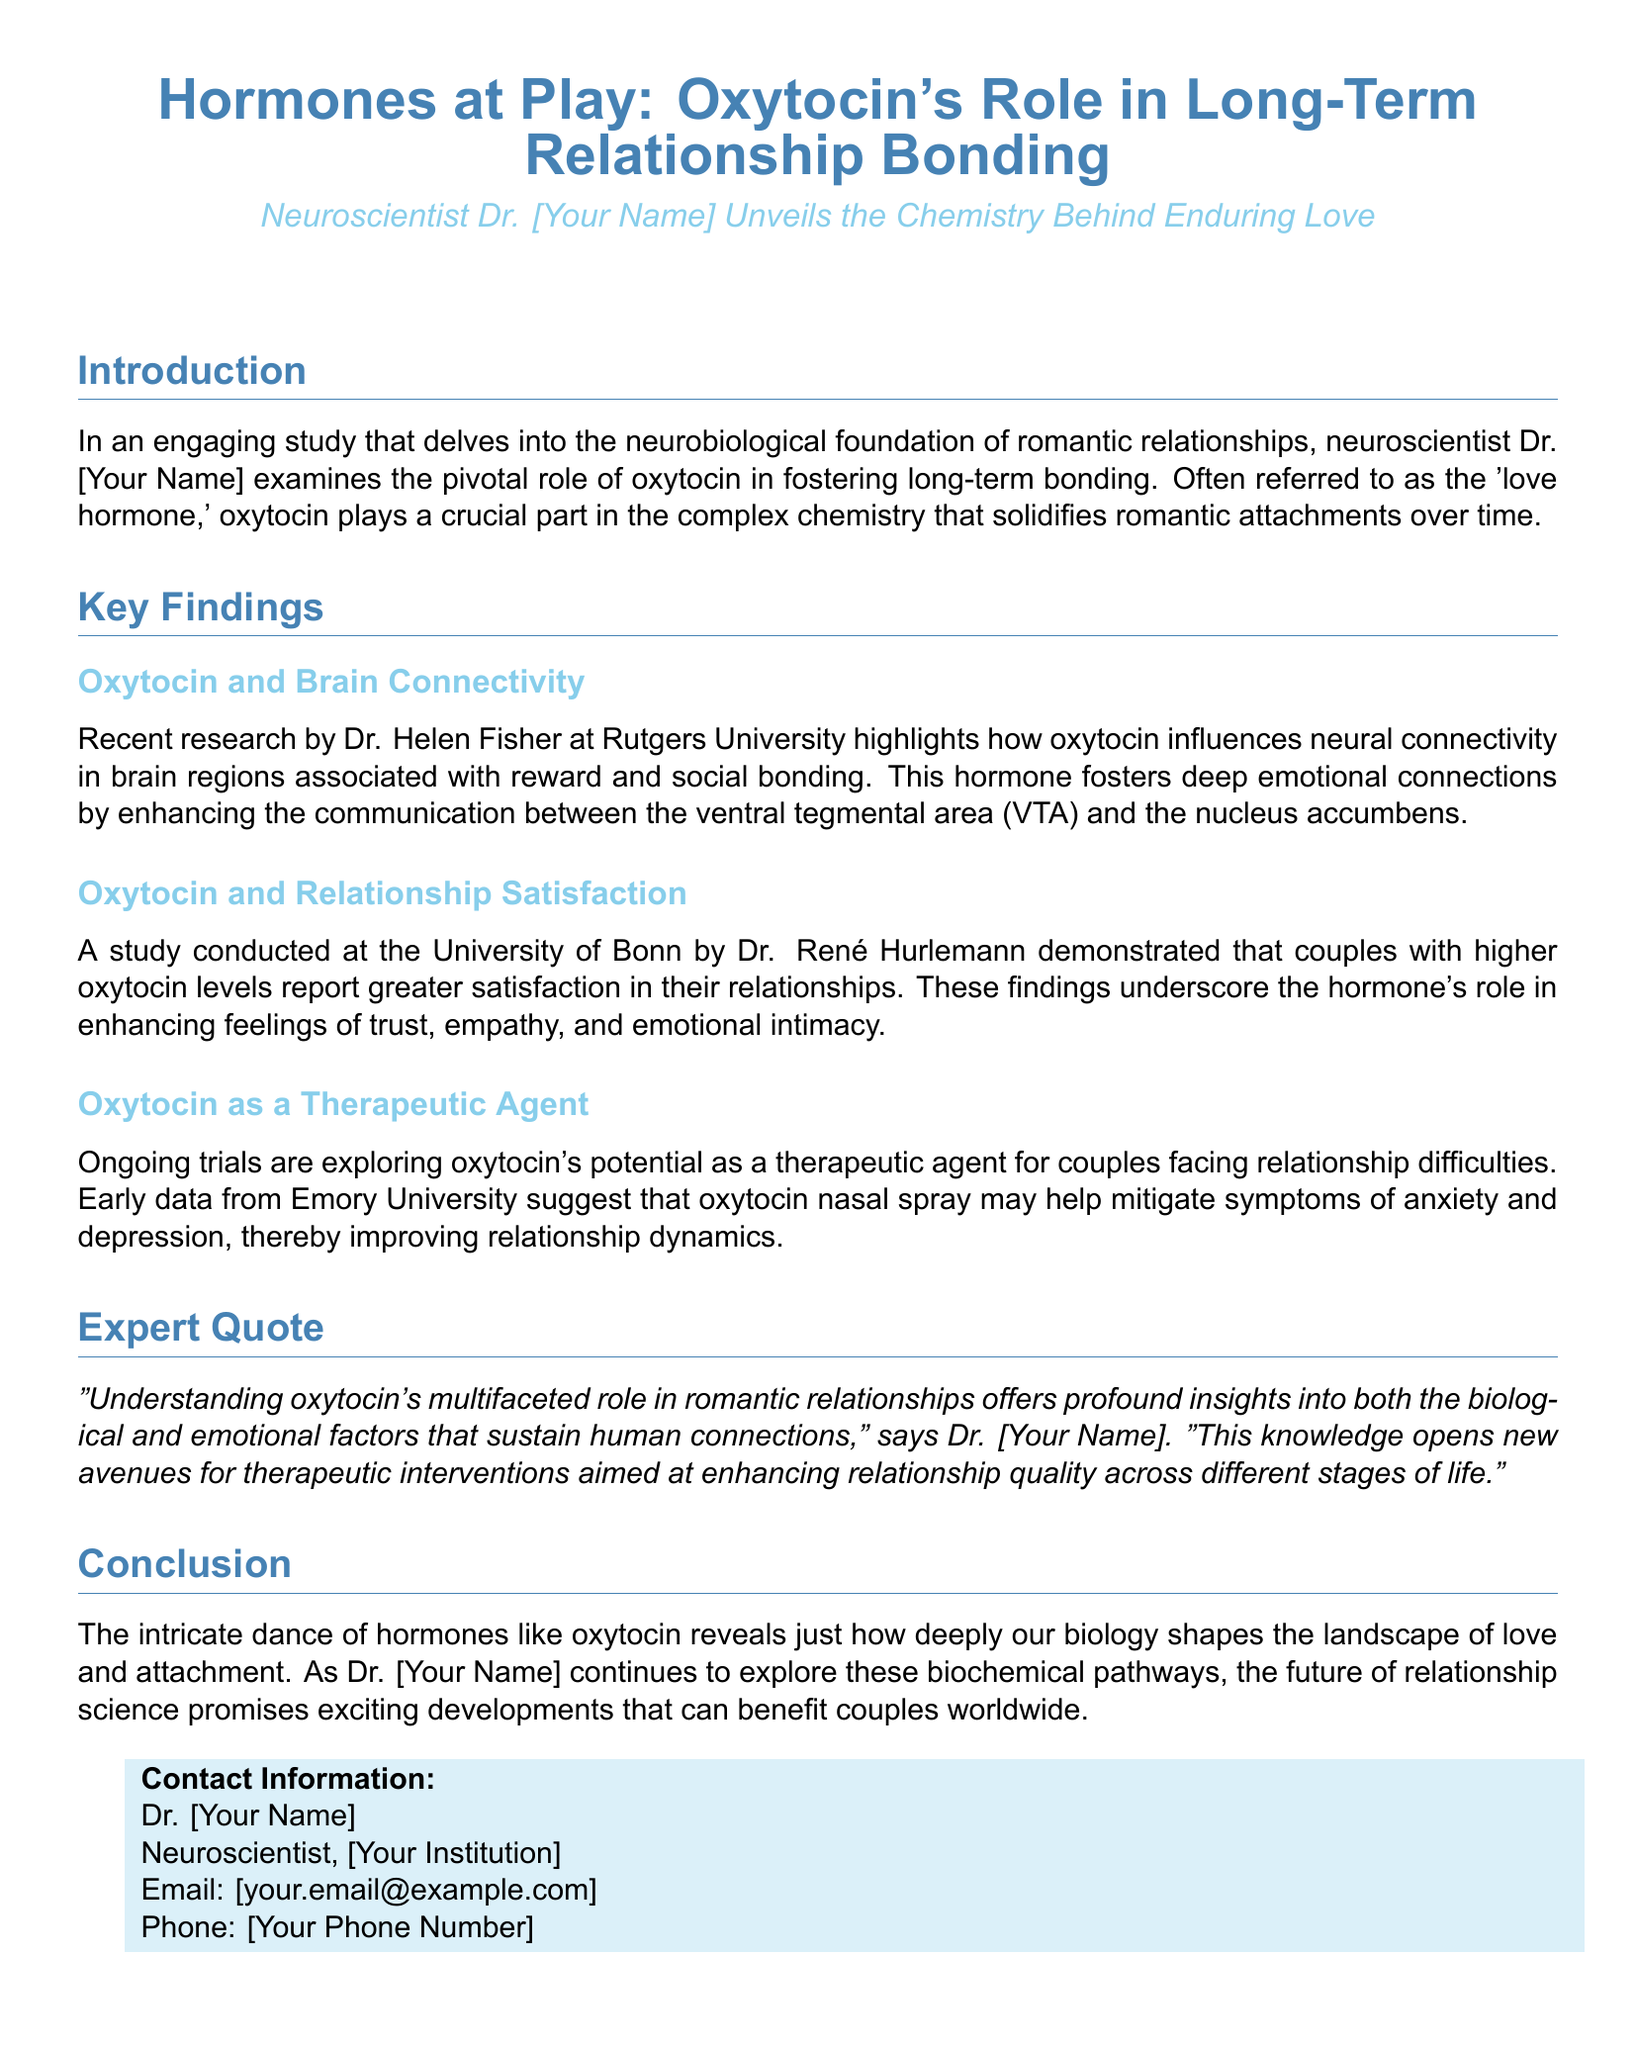What is the title of the study? The title of the study is indicated at the top of the document.
Answer: Hormones at Play: Oxytocin's Role in Long-Term Relationship Bonding Who conducted the research on oxytocin and brain connectivity? The document mentions Dr. Helen Fisher from Rutgers University as the researcher.
Answer: Dr. Helen Fisher What is the primary hormone discussed in the document? The document repeatedly refers to oxytocin as the key hormone.
Answer: Oxytocin What potential therapeutic use of oxytocin is mentioned? According to the document, oxytocin may act as a therapeutic agent for couples facing relationship difficulties.
Answer: Therapeutic agent Which university is associated with the study showing higher oxytocin levels relate to greater relationship satisfaction? The study on oxytocin and relationship satisfaction is associated with the University of Bonn.
Answer: University of Bonn What does Dr. [Your Name] state oxytocin offers insights into? The quote mentions that oxytocin's role provides insights into biological and emotional factors in relationships.
Answer: Biological and emotional factors What is the potential benefit of oxytocin nasal spray according to early data from Emory University? The document states that oxytocin nasal spray may help mitigate symptoms of anxiety and depression.
Answer: Mitigate symptoms of anxiety and depression What aspect of relationships does oxytocin enhance according to the findings? The document describes enhanced feelings of trust, empathy, and emotional intimacy as aspects influenced by oxytocin.
Answer: Trust, empathy, and emotional intimacy 